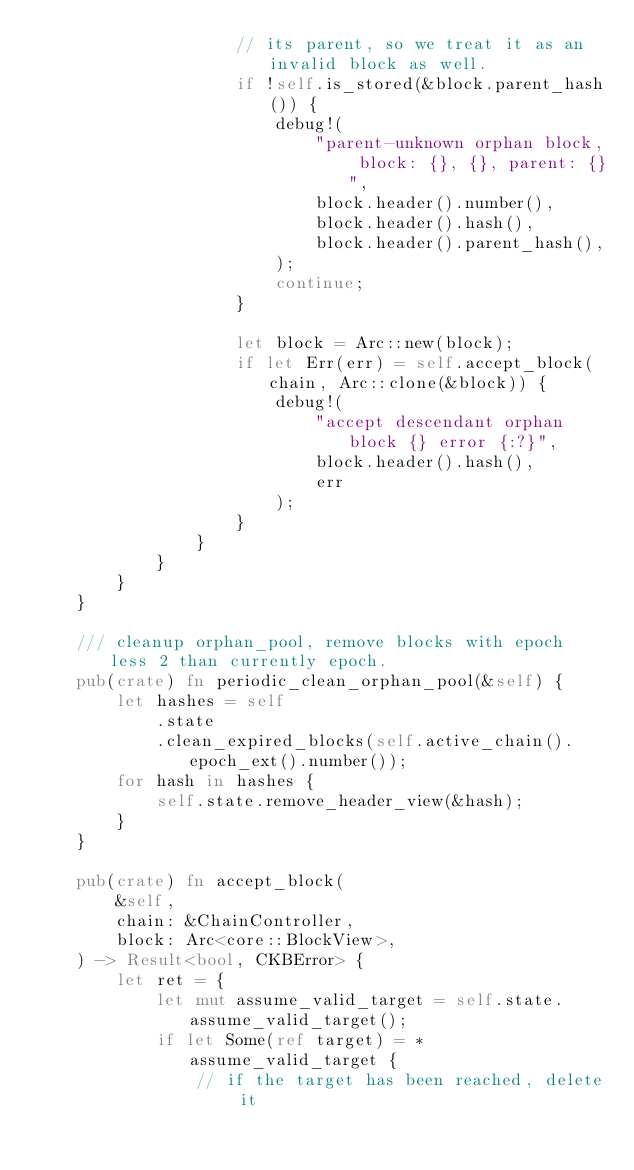<code> <loc_0><loc_0><loc_500><loc_500><_Rust_>                    // its parent, so we treat it as an invalid block as well.
                    if !self.is_stored(&block.parent_hash()) {
                        debug!(
                            "parent-unknown orphan block, block: {}, {}, parent: {}",
                            block.header().number(),
                            block.header().hash(),
                            block.header().parent_hash(),
                        );
                        continue;
                    }

                    let block = Arc::new(block);
                    if let Err(err) = self.accept_block(chain, Arc::clone(&block)) {
                        debug!(
                            "accept descendant orphan block {} error {:?}",
                            block.header().hash(),
                            err
                        );
                    }
                }
            }
        }
    }

    /// cleanup orphan_pool, remove blocks with epoch less 2 than currently epoch.
    pub(crate) fn periodic_clean_orphan_pool(&self) {
        let hashes = self
            .state
            .clean_expired_blocks(self.active_chain().epoch_ext().number());
        for hash in hashes {
            self.state.remove_header_view(&hash);
        }
    }

    pub(crate) fn accept_block(
        &self,
        chain: &ChainController,
        block: Arc<core::BlockView>,
    ) -> Result<bool, CKBError> {
        let ret = {
            let mut assume_valid_target = self.state.assume_valid_target();
            if let Some(ref target) = *assume_valid_target {
                // if the target has been reached, delete it</code> 